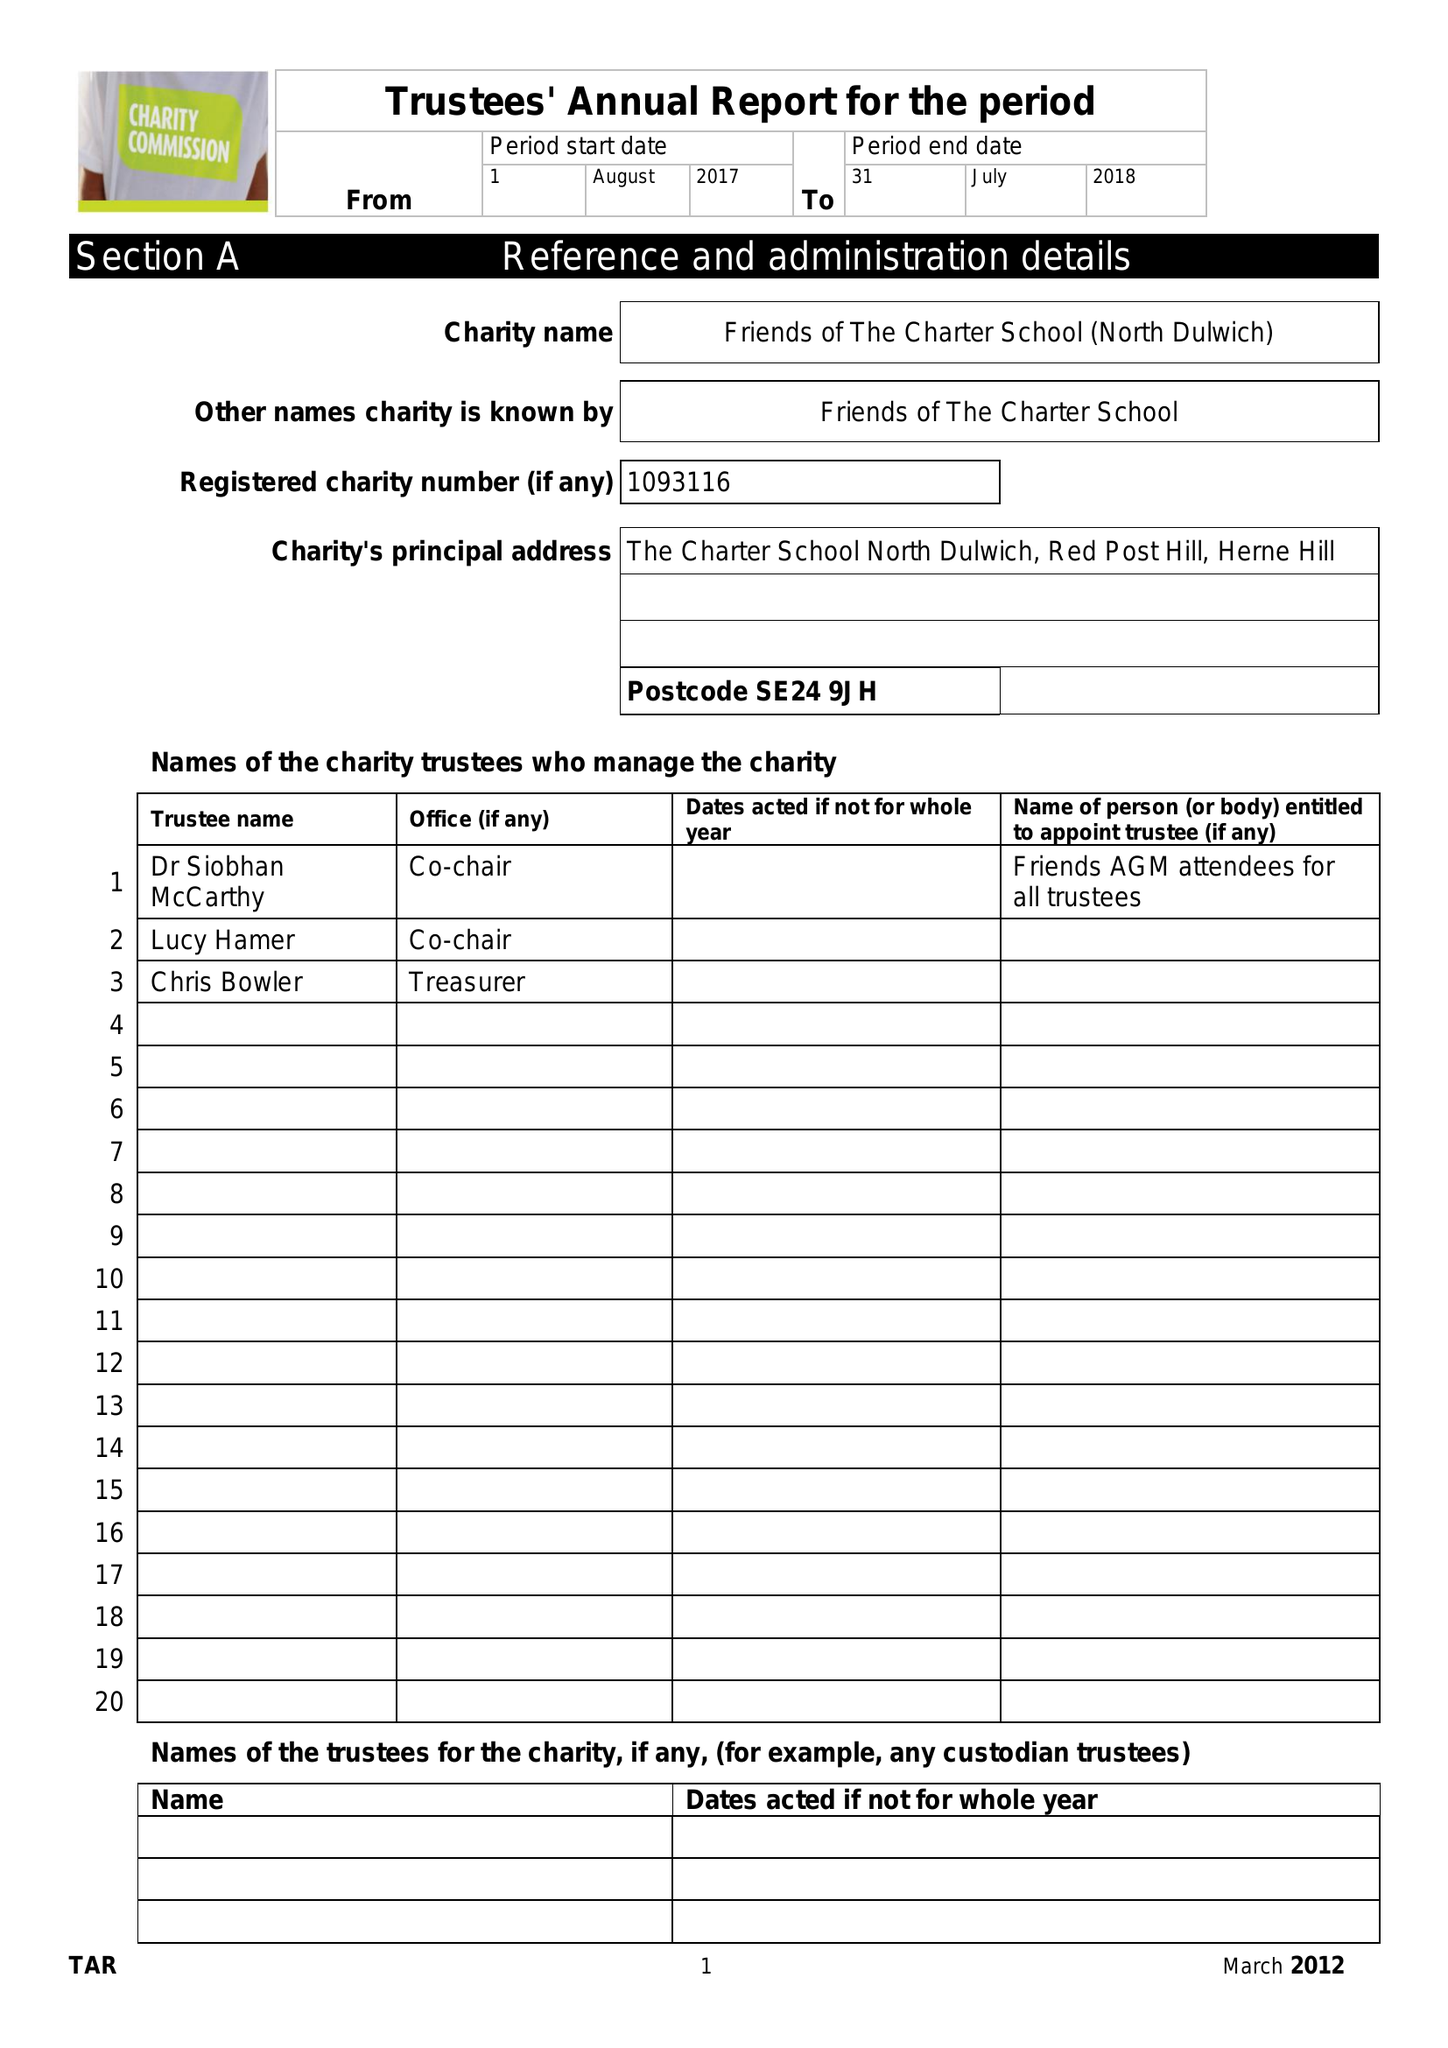What is the value for the charity_number?
Answer the question using a single word or phrase. 1093116 